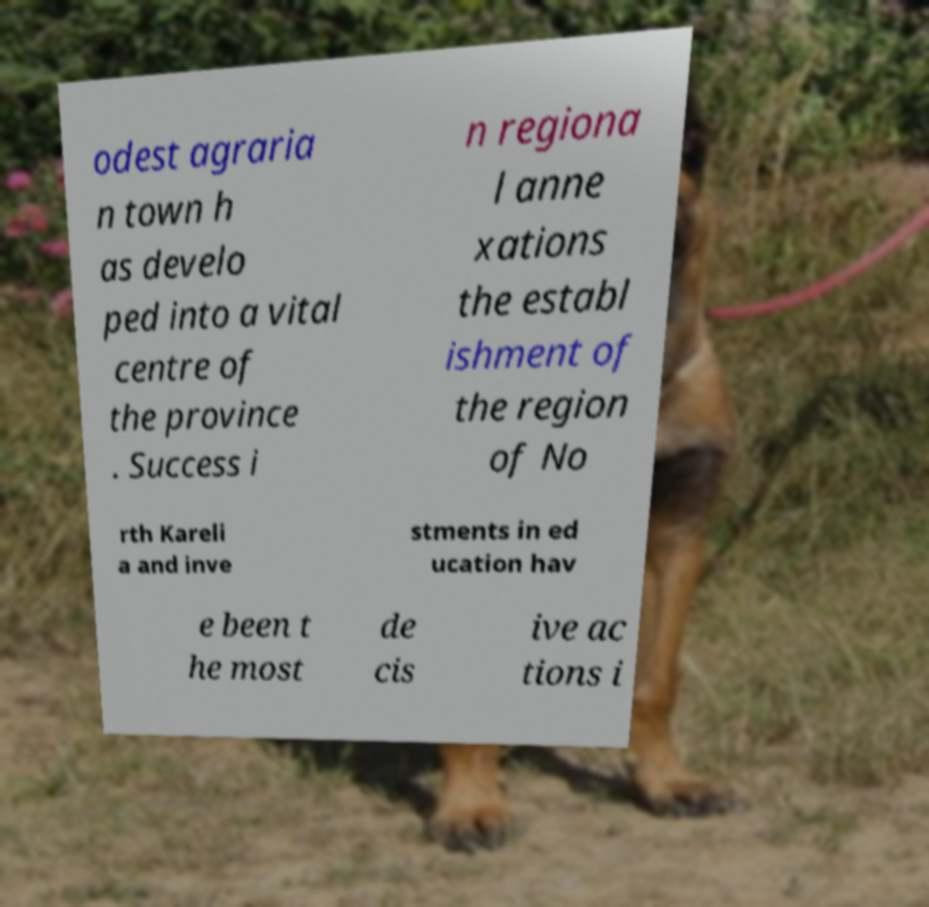What messages or text are displayed in this image? I need them in a readable, typed format. odest agraria n town h as develo ped into a vital centre of the province . Success i n regiona l anne xations the establ ishment of the region of No rth Kareli a and inve stments in ed ucation hav e been t he most de cis ive ac tions i 